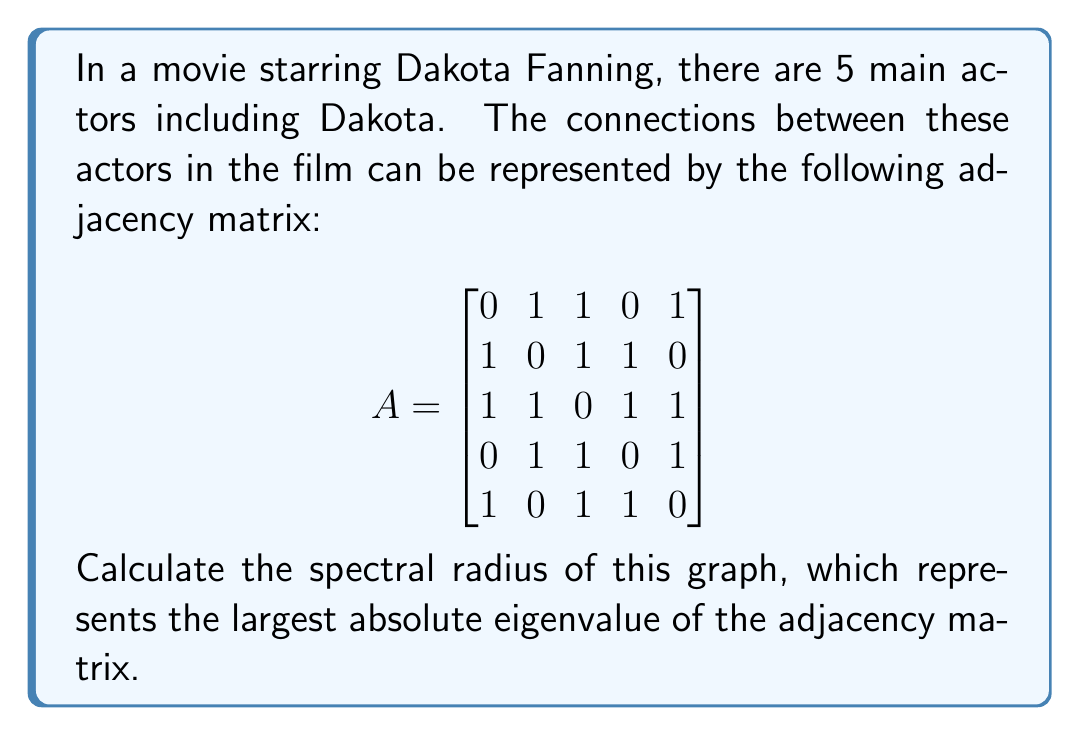Teach me how to tackle this problem. To find the spectral radius, we need to follow these steps:

1) First, we need to find the characteristic polynomial of the adjacency matrix A:
   $$det(A - \lambda I) = 0$$

2) Expanding this determinant:
   $$\begin{vmatrix}
   -\lambda & 1 & 1 & 0 & 1\\
   1 & -\lambda & 1 & 1 & 0\\
   1 & 1 & -\lambda & 1 & 1\\
   0 & 1 & 1 & -\lambda & 1\\
   1 & 0 & 1 & 1 & -\lambda
   \end{vmatrix} = 0$$

3) Solving this equation (which can be done using computer algebra systems due to its complexity) yields the characteristic polynomial:
   $$\lambda^5 - 8\lambda^3 - 8\lambda^2 + 7\lambda + 3 = 0$$

4) The roots of this polynomial are the eigenvalues of A. They are approximately:
   $$\lambda_1 \approx 2.8136, \lambda_2 \approx -1.7485, \lambda_3 \approx 0.8136, \lambda_4 \approx -0.8136, \lambda_5 \approx -0.0651$$

5) The spectral radius is the largest absolute value among these eigenvalues:
   $$\rho(A) = \max(|\lambda_i|) = |\lambda_1| \approx 2.8136$$

Therefore, the spectral radius of the graph is approximately 2.8136.
Answer: $2.8136$ (rounded to 4 decimal places) 